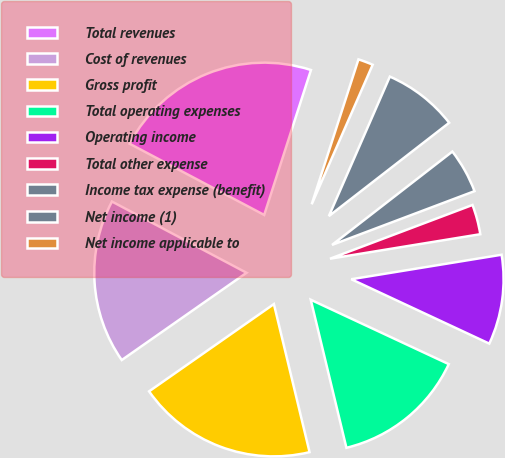Convert chart. <chart><loc_0><loc_0><loc_500><loc_500><pie_chart><fcel>Total revenues<fcel>Cost of revenues<fcel>Gross profit<fcel>Total operating expenses<fcel>Operating income<fcel>Total other expense<fcel>Income tax expense (benefit)<fcel>Net income (1)<fcel>Net income applicable to<nl><fcel>22.22%<fcel>17.46%<fcel>19.05%<fcel>14.29%<fcel>9.52%<fcel>3.17%<fcel>4.76%<fcel>7.94%<fcel>1.59%<nl></chart> 